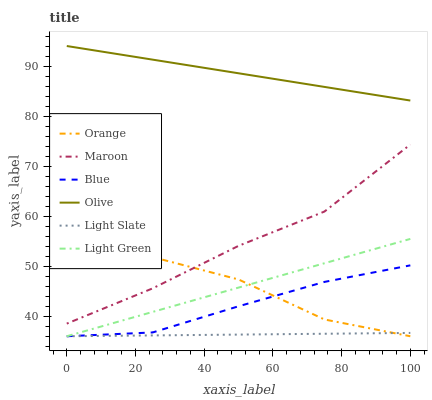Does Maroon have the minimum area under the curve?
Answer yes or no. No. Does Maroon have the maximum area under the curve?
Answer yes or no. No. Is Maroon the smoothest?
Answer yes or no. No. Is Maroon the roughest?
Answer yes or no. No. Does Maroon have the lowest value?
Answer yes or no. No. Does Maroon have the highest value?
Answer yes or no. No. Is Light Green less than Maroon?
Answer yes or no. Yes. Is Maroon greater than Blue?
Answer yes or no. Yes. Does Light Green intersect Maroon?
Answer yes or no. No. 